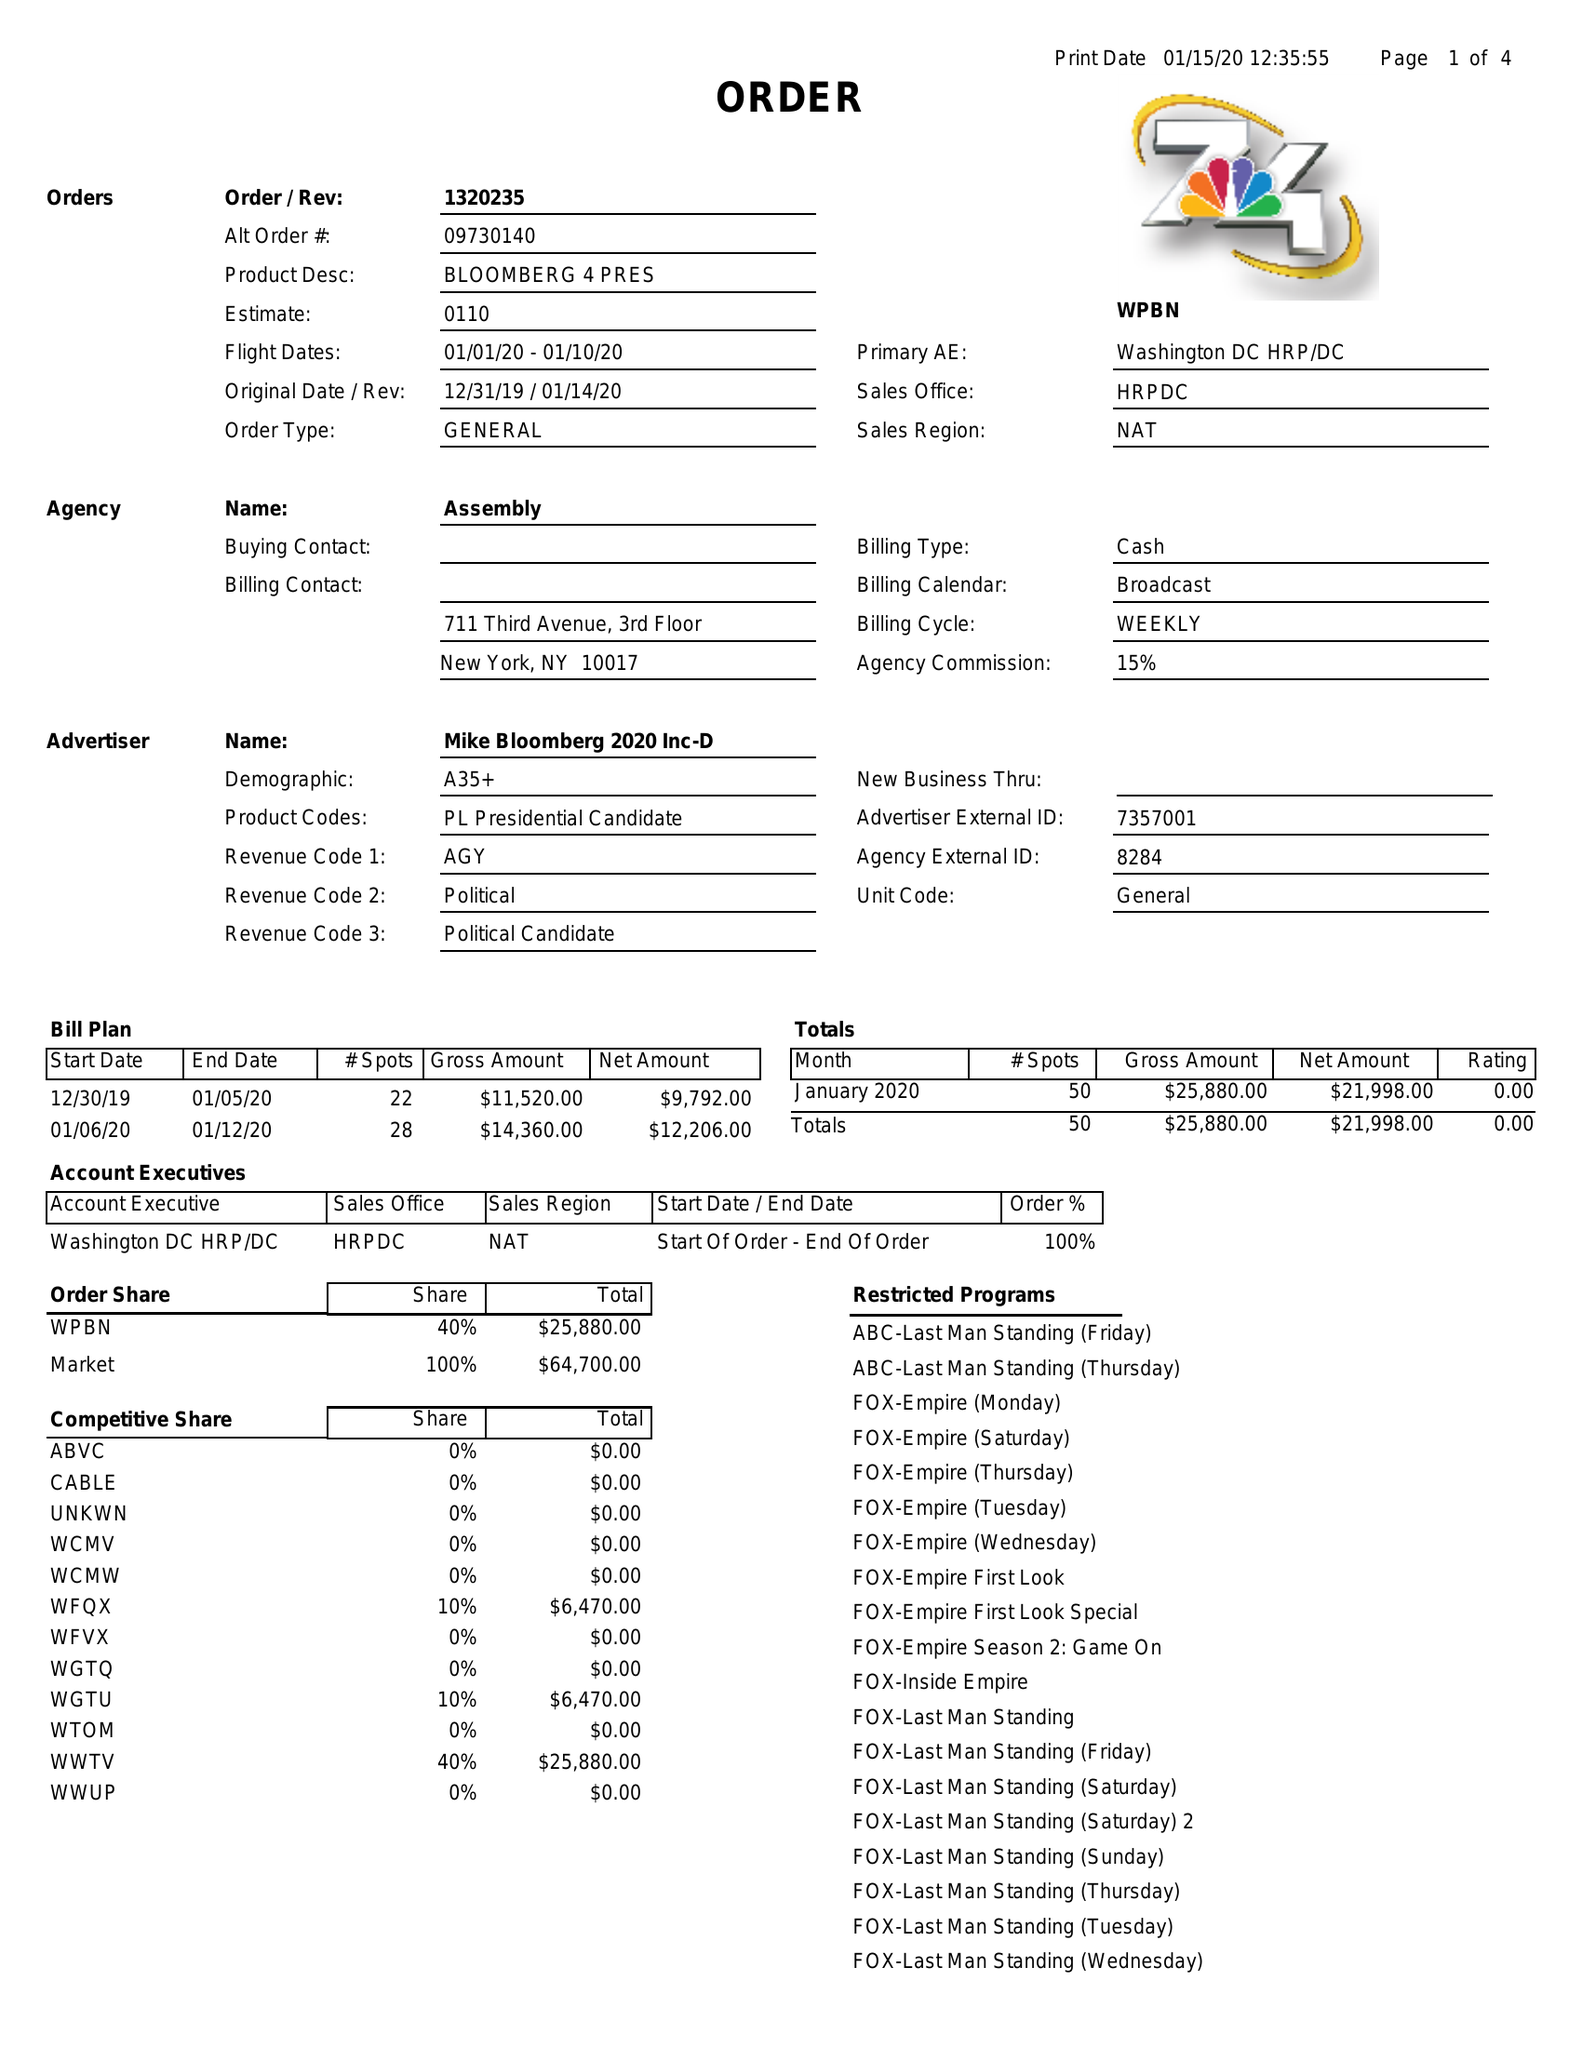What is the value for the gross_amount?
Answer the question using a single word or phrase. 25880.00 